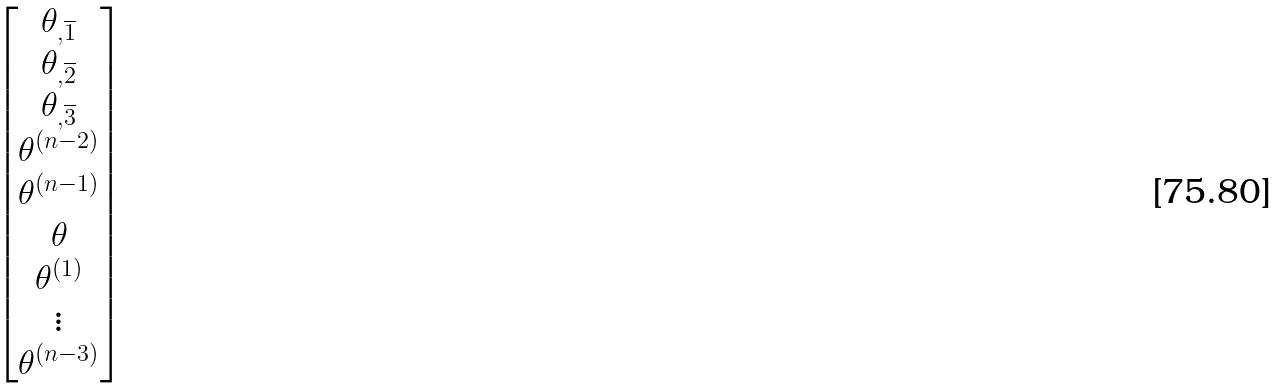Convert formula to latex. <formula><loc_0><loc_0><loc_500><loc_500>\begin{bmatrix} \theta _ { , \overline { 1 } } \\ \theta _ { , \overline { 2 } } \\ \theta _ { , \overline { 3 } } \\ \theta ^ { ( n - 2 ) } \\ \theta ^ { ( n - 1 ) } \\ \theta \\ \theta ^ { ( 1 ) } \\ \vdots \\ \theta ^ { ( n - 3 ) } \end{bmatrix}</formula> 